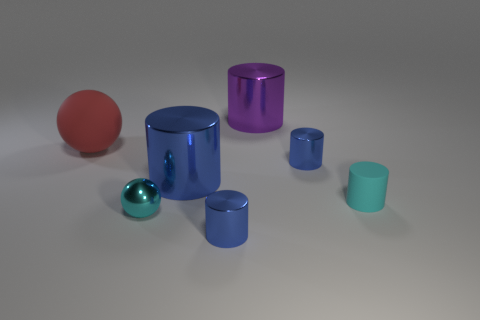Does the rubber sphere have the same size as the blue cylinder that is to the right of the purple thing?
Provide a succinct answer. No. How many other objects are the same size as the cyan rubber cylinder?
Offer a terse response. 3. What number of other things are the same color as the tiny sphere?
Make the answer very short. 1. Are there any other things that have the same size as the red thing?
Keep it short and to the point. Yes. How many other objects are there of the same shape as the big red rubber object?
Give a very brief answer. 1. Is the size of the cyan shiny ball the same as the red rubber ball?
Make the answer very short. No. Is there a big gray block?
Offer a terse response. No. Is there any other thing that has the same material as the big red sphere?
Your response must be concise. Yes. Is there a purple ball made of the same material as the small cyan cylinder?
Ensure brevity in your answer.  No. There is a cyan object that is the same size as the cyan metallic ball; what is it made of?
Give a very brief answer. Rubber. 